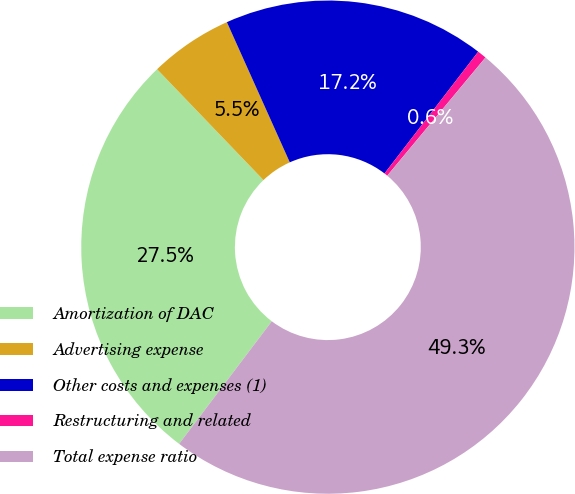Convert chart. <chart><loc_0><loc_0><loc_500><loc_500><pie_chart><fcel>Amortization of DAC<fcel>Advertising expense<fcel>Other costs and expenses (1)<fcel>Restructuring and related<fcel>Total expense ratio<nl><fcel>27.52%<fcel>5.46%<fcel>17.15%<fcel>0.6%<fcel>49.26%<nl></chart> 